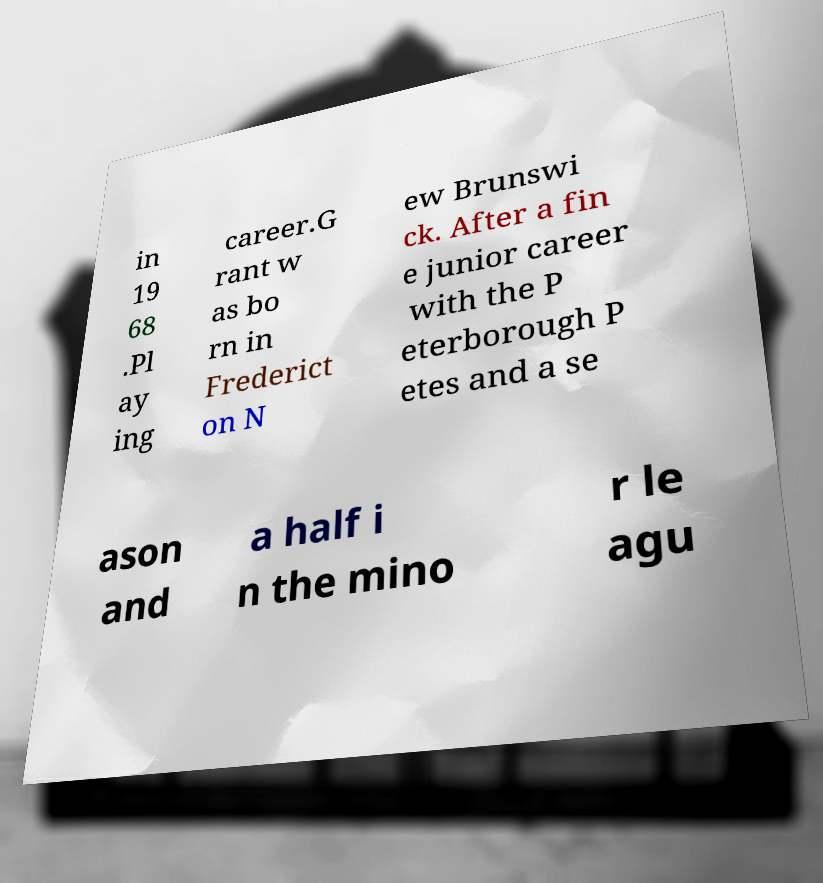Please identify and transcribe the text found in this image. in 19 68 .Pl ay ing career.G rant w as bo rn in Frederict on N ew Brunswi ck. After a fin e junior career with the P eterborough P etes and a se ason and a half i n the mino r le agu 